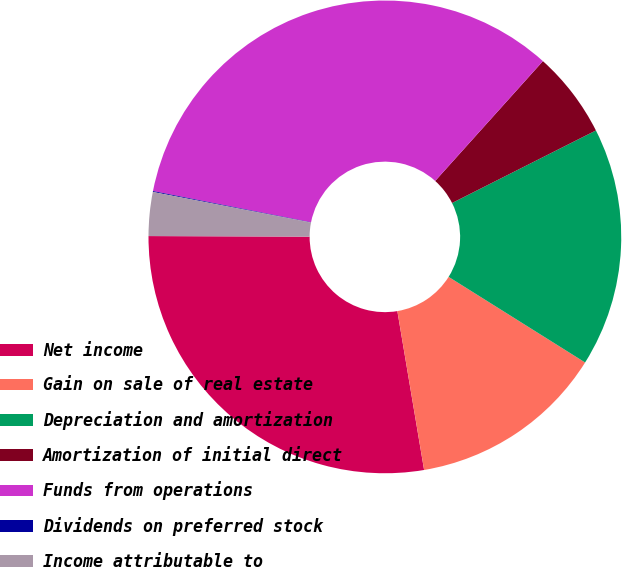Convert chart to OTSL. <chart><loc_0><loc_0><loc_500><loc_500><pie_chart><fcel>Net income<fcel>Gain on sale of real estate<fcel>Depreciation and amortization<fcel>Amortization of initial direct<fcel>Funds from operations<fcel>Dividends on preferred stock<fcel>Income attributable to<nl><fcel>27.71%<fcel>13.43%<fcel>16.35%<fcel>5.91%<fcel>33.55%<fcel>0.06%<fcel>2.99%<nl></chart> 